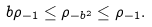Convert formula to latex. <formula><loc_0><loc_0><loc_500><loc_500>b \rho _ { - 1 } \leq \rho _ { - b ^ { 2 } } \leq \rho _ { - 1 } .</formula> 